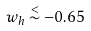<formula> <loc_0><loc_0><loc_500><loc_500>w _ { h } \stackrel { < } { \sim } - 0 . 6 5</formula> 